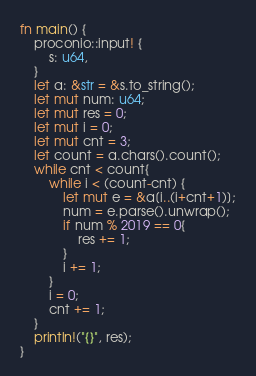Convert code to text. <code><loc_0><loc_0><loc_500><loc_500><_Rust_>fn main() {
    proconio::input! {
        s: u64,
    }
    let a: &str = &s.to_string();
    let mut num: u64;
    let mut res = 0;
    let mut i = 0;
    let mut cnt = 3;
    let count = a.chars().count();
    while cnt < count{
        while i < (count-cnt) {
            let mut e = &a[i..(i+cnt+1)];
            num = e.parse().unwrap();
            if num % 2019 == 0{
                res += 1;
            }
            i += 1;
        }
        i = 0;
        cnt += 1;
    }
    println!("{}", res);
}</code> 